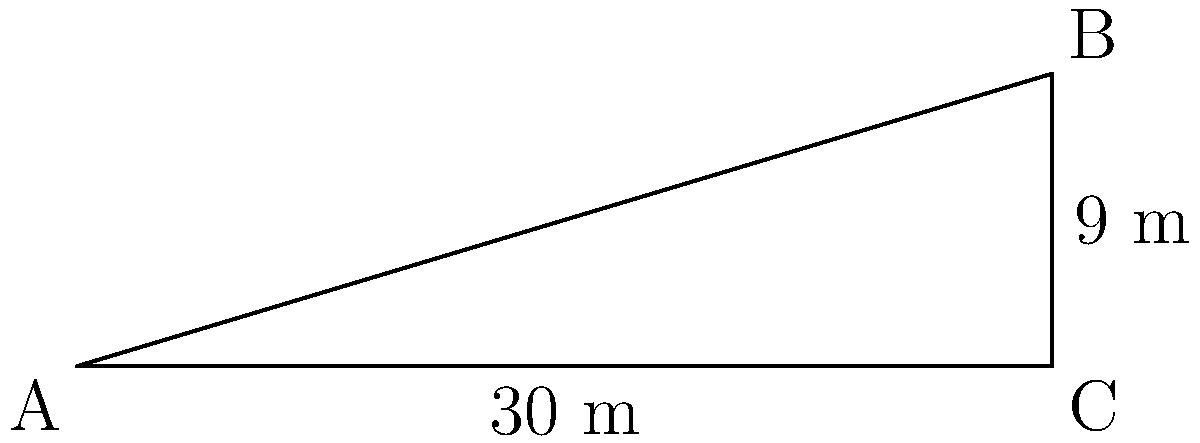As part of a road construction project on a hillside, you need to calculate the slope and angle of the road for proper drainage. The road stretches 30 meters horizontally and rises 9 meters vertically. Calculate:

a) The slope of the road as a percentage.
b) The angle of inclination of the road in degrees.

Round your answers to two decimal places. Let's approach this step-by-step:

1) First, let's identify our known values:
   - Horizontal distance = 30 m
   - Vertical rise = 9 m

2) To calculate the slope as a percentage:
   
   a) The formula for slope as a percentage is:
      $$ \text{Slope (%)} = \frac{\text{Vertical Rise}}{\text{Horizontal Distance}} \times 100\% $$
   
   b) Plugging in our values:
      $$ \text{Slope (%)} = \frac{9 \text{ m}}{30 \text{ m}} \times 100\% = 0.3 \times 100\% = 30\% $$

3) To calculate the angle of inclination:
   
   a) We can use the trigonometric function tangent:
      $$ \tan \theta = \frac{\text{Opposite}}{\text{Adjacent}} = \frac{\text{Vertical Rise}}{\text{Horizontal Distance}} $$
   
   b) Plugging in our values:
      $$ \tan \theta = \frac{9}{30} = 0.3 $$
   
   c) To find $\theta$, we take the inverse tangent (arctan):
      $$ \theta = \arctan(0.3) $$
   
   d) Using a calculator or trigonometric tables:
      $$ \theta \approx 16.70^\circ $$

Therefore, the slope is 30.00% and the angle of inclination is 16.70°.
Answer: a) 30.00%
b) 16.70° 